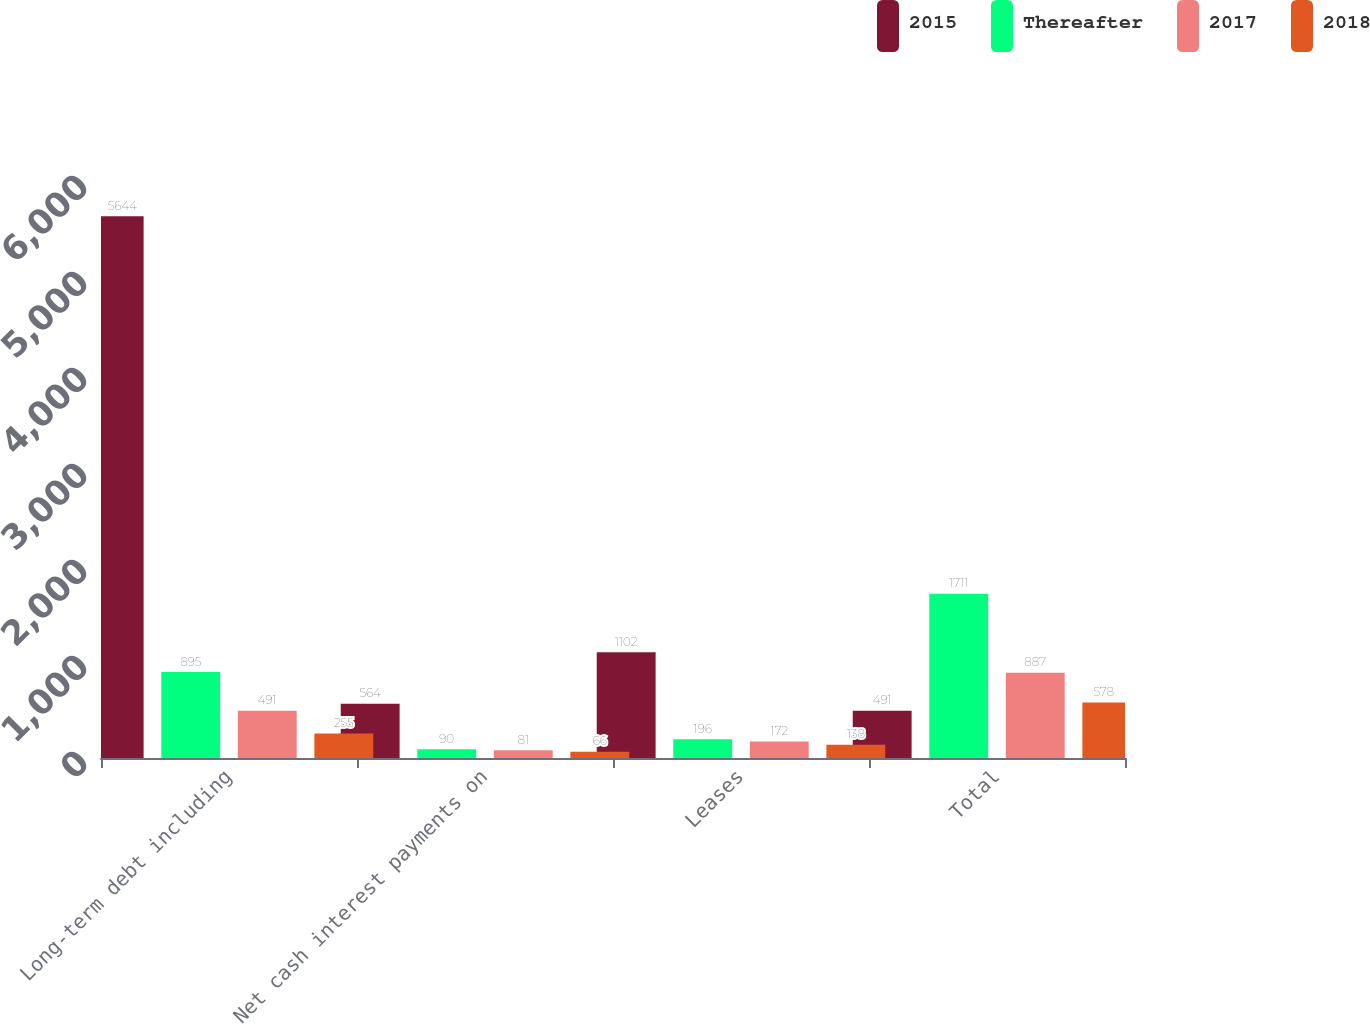<chart> <loc_0><loc_0><loc_500><loc_500><stacked_bar_chart><ecel><fcel>Long-term debt including<fcel>Net cash interest payments on<fcel>Leases<fcel>Total<nl><fcel>2015<fcel>5644<fcel>564<fcel>1102<fcel>491<nl><fcel>Thereafter<fcel>895<fcel>90<fcel>196<fcel>1711<nl><fcel>2017<fcel>491<fcel>81<fcel>172<fcel>887<nl><fcel>2018<fcel>255<fcel>66<fcel>138<fcel>578<nl></chart> 